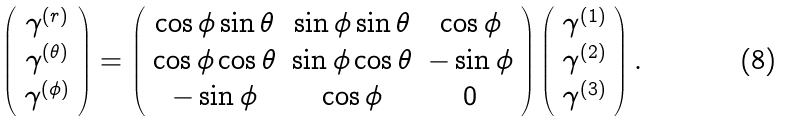Convert formula to latex. <formula><loc_0><loc_0><loc_500><loc_500>\left ( \begin{array} { c } \gamma ^ { \left ( r \right ) } \\ \gamma ^ { \left ( \theta \right ) } \\ \gamma ^ { \left ( \phi \right ) } \end{array} \right ) = \left ( \begin{array} { c c c } \cos \phi \sin \theta & \sin \phi \sin \theta & \cos \phi \\ \cos \phi \cos \theta & \sin \phi \cos \theta & - \sin \phi \\ - \sin \phi & \cos \phi & 0 \end{array} \right ) \left ( \begin{array} { c } \gamma ^ { \left ( 1 \right ) } \\ \gamma ^ { \left ( 2 \right ) } \\ \gamma ^ { \left ( 3 \right ) } \end{array} \right ) .</formula> 